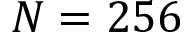<formula> <loc_0><loc_0><loc_500><loc_500>N = 2 5 6</formula> 